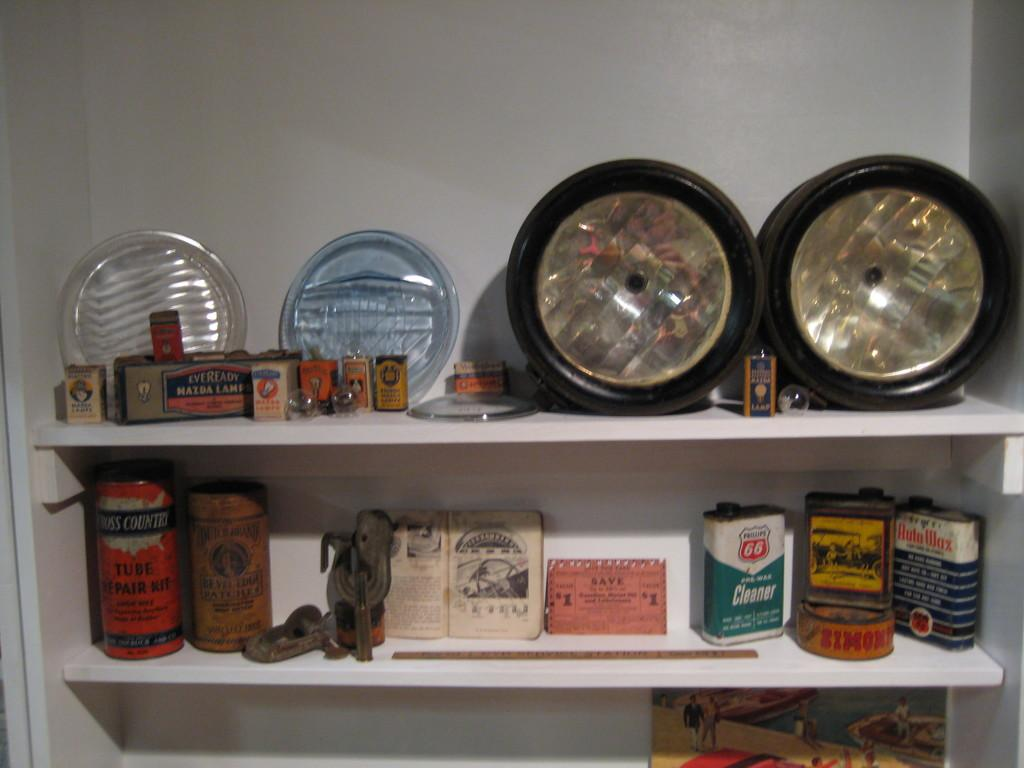<image>
Offer a succinct explanation of the picture presented. Two white shelves with auto supplies on it and one of the containers says Auto Wax in red letters with a white background. 